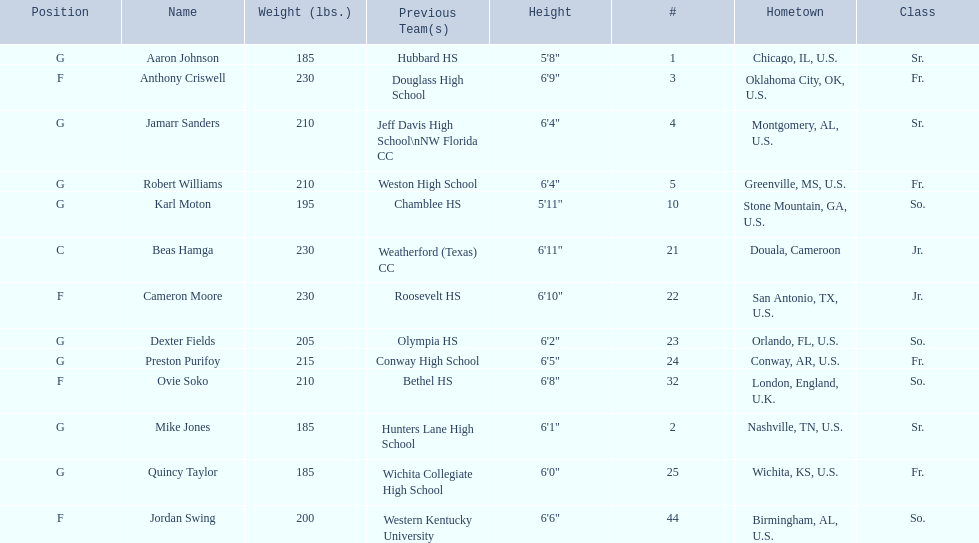Which are all of the players? Aaron Johnson, Anthony Criswell, Jamarr Sanders, Robert Williams, Karl Moton, Beas Hamga, Cameron Moore, Dexter Fields, Preston Purifoy, Ovie Soko, Mike Jones, Quincy Taylor, Jordan Swing. Which players are from a country outside of the u.s.? Beas Hamga, Ovie Soko. Aside from soko, who else is not from the u.s.? Beas Hamga. 